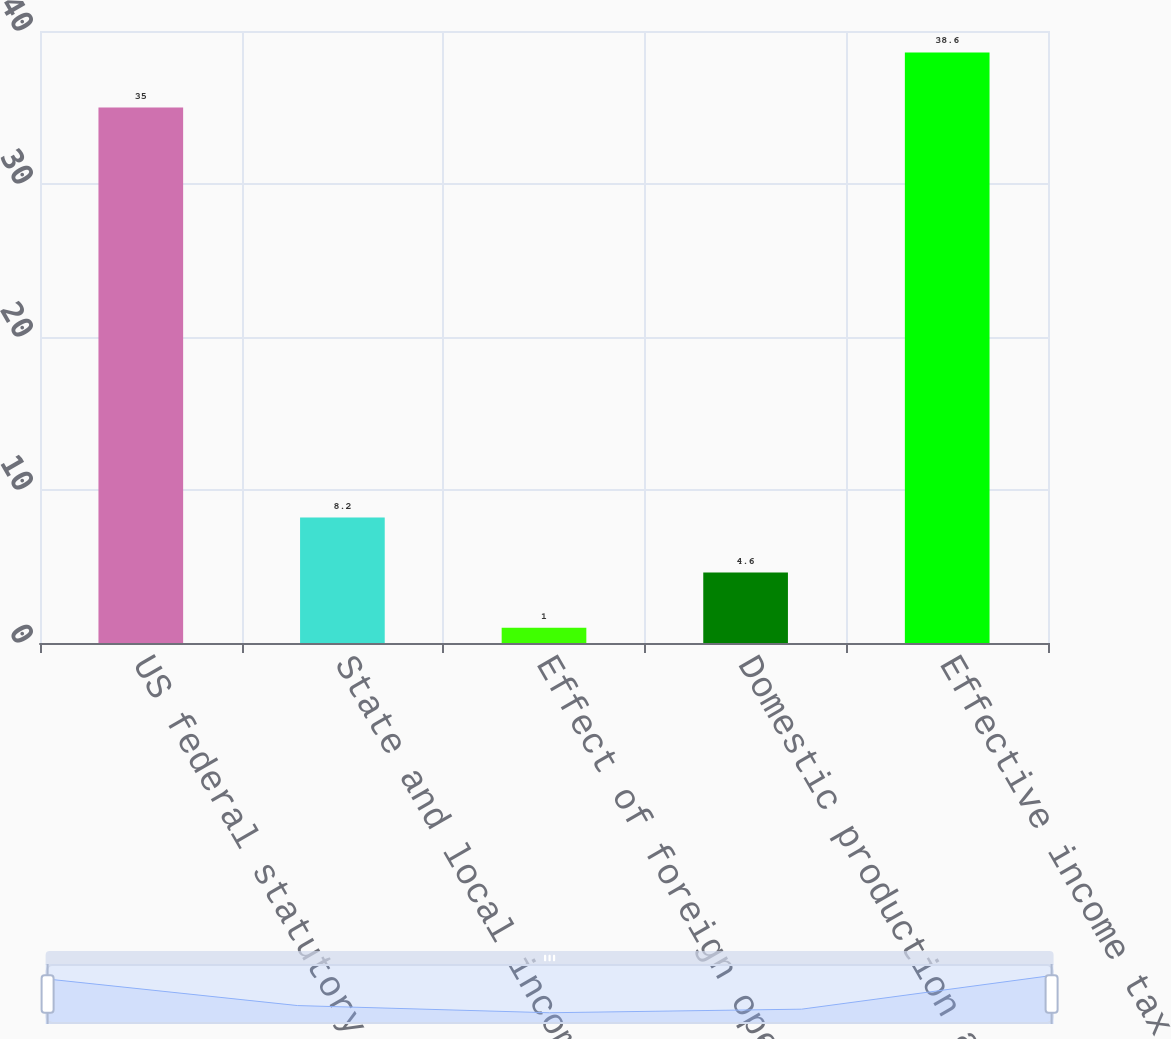<chart> <loc_0><loc_0><loc_500><loc_500><bar_chart><fcel>US federal statutory income<fcel>State and local income taxes<fcel>Effect of foreign operations<fcel>Domestic production activity<fcel>Effective income tax rate<nl><fcel>35<fcel>8.2<fcel>1<fcel>4.6<fcel>38.6<nl></chart> 